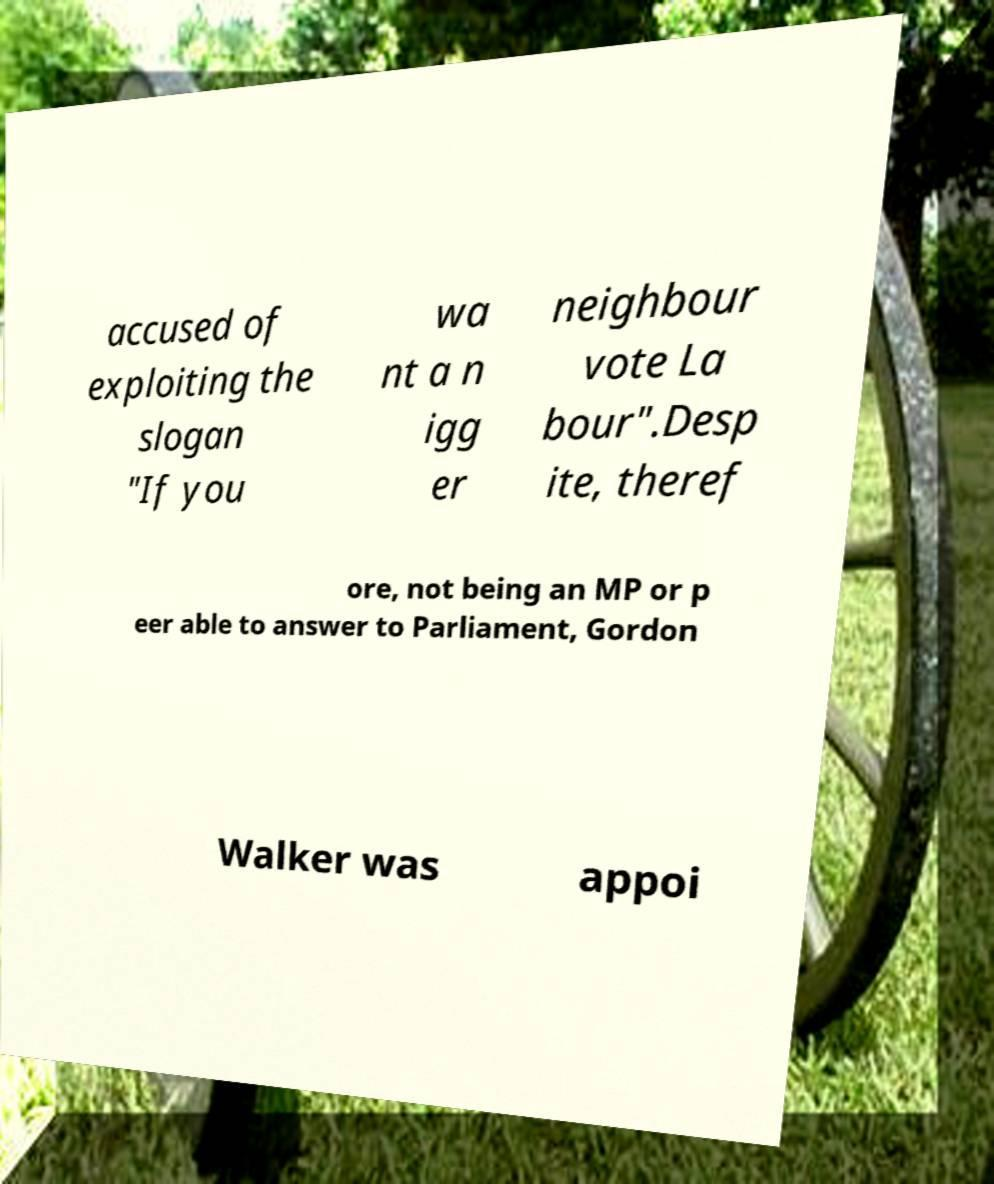For documentation purposes, I need the text within this image transcribed. Could you provide that? accused of exploiting the slogan "If you wa nt a n igg er neighbour vote La bour".Desp ite, theref ore, not being an MP or p eer able to answer to Parliament, Gordon Walker was appoi 